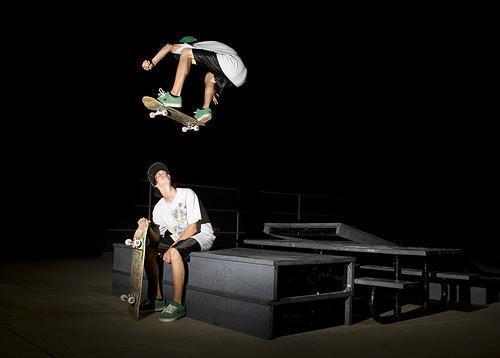How many people are there?
Give a very brief answer. 2. How many benches are there?
Give a very brief answer. 2. How many ducks have orange hats?
Give a very brief answer. 0. 